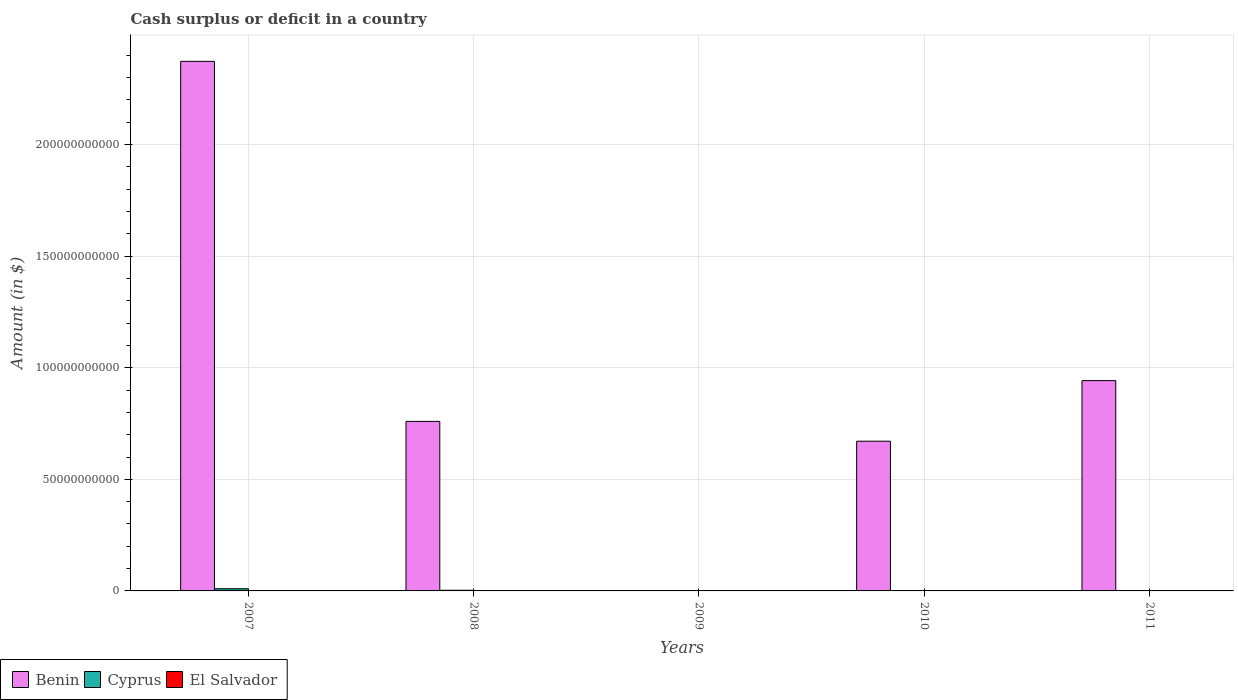Are the number of bars per tick equal to the number of legend labels?
Make the answer very short. No. How many bars are there on the 2nd tick from the left?
Your answer should be very brief. 3. What is the label of the 1st group of bars from the left?
Keep it short and to the point. 2007. In how many cases, is the number of bars for a given year not equal to the number of legend labels?
Your response must be concise. 3. What is the amount of cash surplus or deficit in Cyprus in 2008?
Provide a succinct answer. 2.89e+08. Across all years, what is the maximum amount of cash surplus or deficit in Benin?
Offer a very short reply. 2.37e+11. Across all years, what is the minimum amount of cash surplus or deficit in Benin?
Provide a short and direct response. 0. In which year was the amount of cash surplus or deficit in El Salvador maximum?
Keep it short and to the point. 2007. What is the total amount of cash surplus or deficit in Benin in the graph?
Make the answer very short. 4.75e+11. What is the difference between the amount of cash surplus or deficit in Benin in 2007 and that in 2008?
Make the answer very short. 1.61e+11. What is the difference between the amount of cash surplus or deficit in Cyprus in 2008 and the amount of cash surplus or deficit in El Salvador in 2007?
Offer a very short reply. 1.21e+08. What is the average amount of cash surplus or deficit in Cyprus per year?
Keep it short and to the point. 2.56e+08. In the year 2008, what is the difference between the amount of cash surplus or deficit in El Salvador and amount of cash surplus or deficit in Cyprus?
Give a very brief answer. -2.18e+08. In how many years, is the amount of cash surplus or deficit in El Salvador greater than 220000000000 $?
Offer a terse response. 0. What is the ratio of the amount of cash surplus or deficit in Benin in 2007 to that in 2010?
Your answer should be very brief. 3.54. Is the amount of cash surplus or deficit in Benin in 2007 less than that in 2010?
Provide a succinct answer. No. What is the difference between the highest and the second highest amount of cash surplus or deficit in Benin?
Give a very brief answer. 1.43e+11. What is the difference between the highest and the lowest amount of cash surplus or deficit in Benin?
Your answer should be compact. 2.37e+11. Is it the case that in every year, the sum of the amount of cash surplus or deficit in Benin and amount of cash surplus or deficit in El Salvador is greater than the amount of cash surplus or deficit in Cyprus?
Provide a succinct answer. No. What is the difference between two consecutive major ticks on the Y-axis?
Your answer should be very brief. 5.00e+1. Does the graph contain any zero values?
Provide a short and direct response. Yes. What is the title of the graph?
Your answer should be very brief. Cash surplus or deficit in a country. What is the label or title of the X-axis?
Provide a succinct answer. Years. What is the label or title of the Y-axis?
Your answer should be compact. Amount (in $). What is the Amount (in $) of Benin in 2007?
Your answer should be compact. 2.37e+11. What is the Amount (in $) of Cyprus in 2007?
Offer a very short reply. 9.90e+08. What is the Amount (in $) in El Salvador in 2007?
Your answer should be very brief. 1.68e+08. What is the Amount (in $) in Benin in 2008?
Offer a terse response. 7.60e+1. What is the Amount (in $) in Cyprus in 2008?
Your response must be concise. 2.89e+08. What is the Amount (in $) in El Salvador in 2008?
Your answer should be compact. 7.12e+07. What is the Amount (in $) in El Salvador in 2009?
Give a very brief answer. 0. What is the Amount (in $) in Benin in 2010?
Provide a succinct answer. 6.71e+1. What is the Amount (in $) in Benin in 2011?
Ensure brevity in your answer.  9.42e+1. What is the Amount (in $) of Cyprus in 2011?
Your answer should be compact. 0. Across all years, what is the maximum Amount (in $) of Benin?
Your answer should be very brief. 2.37e+11. Across all years, what is the maximum Amount (in $) of Cyprus?
Provide a short and direct response. 9.90e+08. Across all years, what is the maximum Amount (in $) in El Salvador?
Your response must be concise. 1.68e+08. Across all years, what is the minimum Amount (in $) in Benin?
Your answer should be compact. 0. What is the total Amount (in $) of Benin in the graph?
Keep it short and to the point. 4.75e+11. What is the total Amount (in $) in Cyprus in the graph?
Offer a very short reply. 1.28e+09. What is the total Amount (in $) of El Salvador in the graph?
Make the answer very short. 2.39e+08. What is the difference between the Amount (in $) in Benin in 2007 and that in 2008?
Your response must be concise. 1.61e+11. What is the difference between the Amount (in $) in Cyprus in 2007 and that in 2008?
Your answer should be compact. 7.01e+08. What is the difference between the Amount (in $) of El Salvador in 2007 and that in 2008?
Give a very brief answer. 9.67e+07. What is the difference between the Amount (in $) of Benin in 2007 and that in 2010?
Provide a short and direct response. 1.70e+11. What is the difference between the Amount (in $) of Benin in 2007 and that in 2011?
Your response must be concise. 1.43e+11. What is the difference between the Amount (in $) of Benin in 2008 and that in 2010?
Provide a succinct answer. 8.88e+09. What is the difference between the Amount (in $) in Benin in 2008 and that in 2011?
Your answer should be very brief. -1.83e+1. What is the difference between the Amount (in $) in Benin in 2010 and that in 2011?
Keep it short and to the point. -2.71e+1. What is the difference between the Amount (in $) of Benin in 2007 and the Amount (in $) of Cyprus in 2008?
Provide a short and direct response. 2.37e+11. What is the difference between the Amount (in $) in Benin in 2007 and the Amount (in $) in El Salvador in 2008?
Your response must be concise. 2.37e+11. What is the difference between the Amount (in $) of Cyprus in 2007 and the Amount (in $) of El Salvador in 2008?
Give a very brief answer. 9.18e+08. What is the average Amount (in $) of Benin per year?
Your answer should be very brief. 9.49e+1. What is the average Amount (in $) of Cyprus per year?
Your answer should be compact. 2.56e+08. What is the average Amount (in $) in El Salvador per year?
Give a very brief answer. 4.78e+07. In the year 2007, what is the difference between the Amount (in $) in Benin and Amount (in $) in Cyprus?
Provide a succinct answer. 2.36e+11. In the year 2007, what is the difference between the Amount (in $) in Benin and Amount (in $) in El Salvador?
Your response must be concise. 2.37e+11. In the year 2007, what is the difference between the Amount (in $) of Cyprus and Amount (in $) of El Salvador?
Keep it short and to the point. 8.22e+08. In the year 2008, what is the difference between the Amount (in $) in Benin and Amount (in $) in Cyprus?
Keep it short and to the point. 7.57e+1. In the year 2008, what is the difference between the Amount (in $) of Benin and Amount (in $) of El Salvador?
Make the answer very short. 7.59e+1. In the year 2008, what is the difference between the Amount (in $) of Cyprus and Amount (in $) of El Salvador?
Keep it short and to the point. 2.18e+08. What is the ratio of the Amount (in $) of Benin in 2007 to that in 2008?
Provide a short and direct response. 3.12. What is the ratio of the Amount (in $) of Cyprus in 2007 to that in 2008?
Offer a very short reply. 3.42. What is the ratio of the Amount (in $) in El Salvador in 2007 to that in 2008?
Your answer should be compact. 2.36. What is the ratio of the Amount (in $) of Benin in 2007 to that in 2010?
Offer a very short reply. 3.54. What is the ratio of the Amount (in $) in Benin in 2007 to that in 2011?
Your response must be concise. 2.52. What is the ratio of the Amount (in $) in Benin in 2008 to that in 2010?
Keep it short and to the point. 1.13. What is the ratio of the Amount (in $) of Benin in 2008 to that in 2011?
Offer a terse response. 0.81. What is the ratio of the Amount (in $) of Benin in 2010 to that in 2011?
Provide a short and direct response. 0.71. What is the difference between the highest and the second highest Amount (in $) of Benin?
Provide a succinct answer. 1.43e+11. What is the difference between the highest and the lowest Amount (in $) in Benin?
Make the answer very short. 2.37e+11. What is the difference between the highest and the lowest Amount (in $) of Cyprus?
Your answer should be compact. 9.90e+08. What is the difference between the highest and the lowest Amount (in $) in El Salvador?
Give a very brief answer. 1.68e+08. 